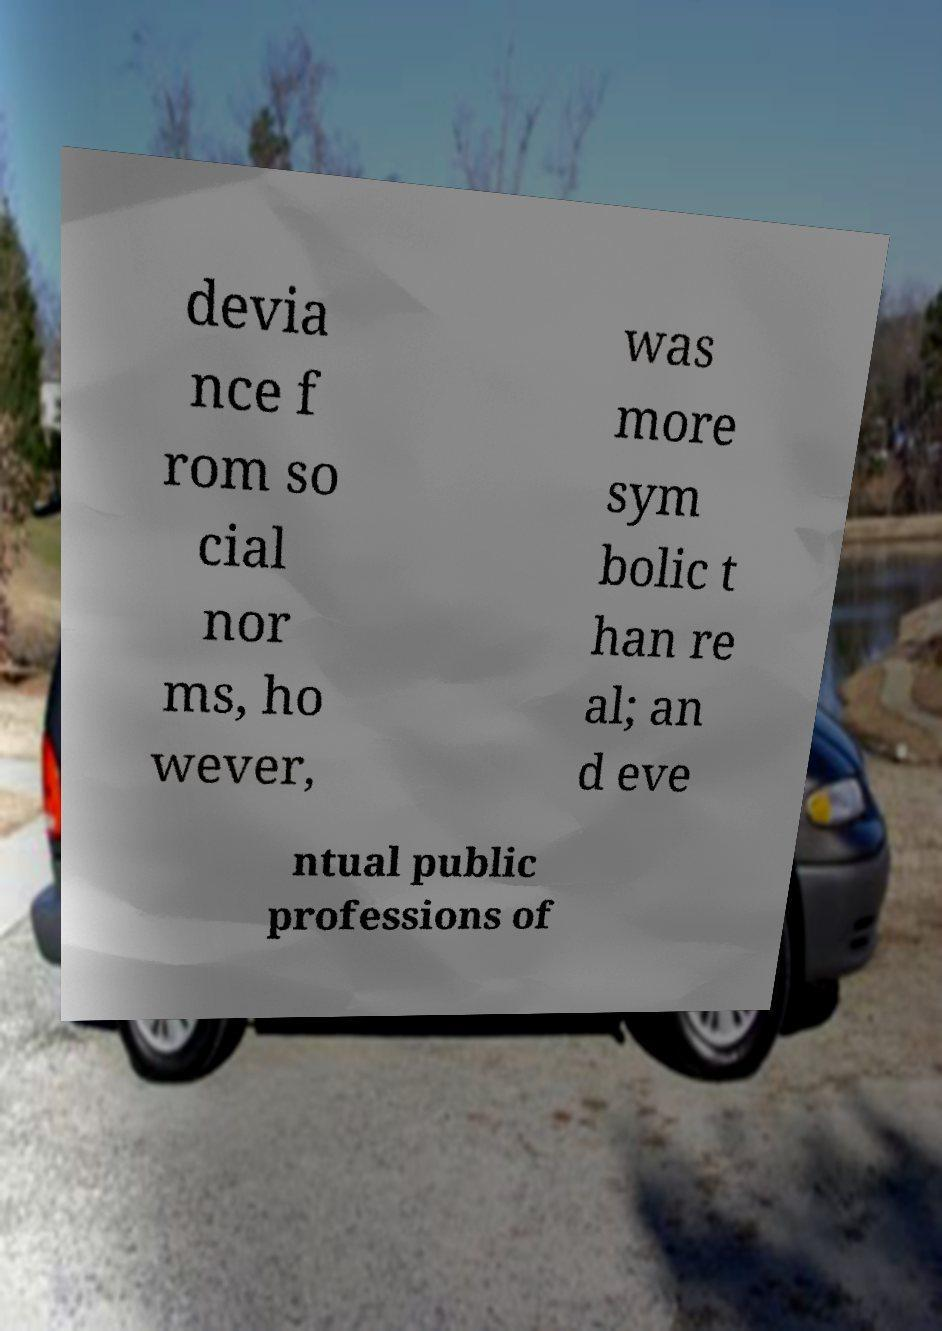Please identify and transcribe the text found in this image. devia nce f rom so cial nor ms, ho wever, was more sym bolic t han re al; an d eve ntual public professions of 